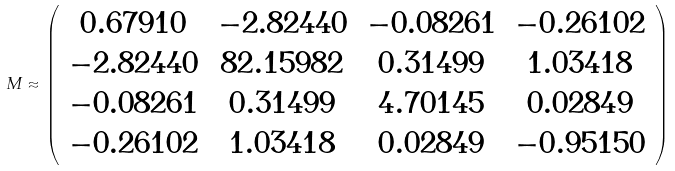<formula> <loc_0><loc_0><loc_500><loc_500>M \approx \left ( \begin{array} { c c c c } 0 . 6 7 9 1 0 & - 2 . 8 2 4 4 0 & - 0 . 0 8 2 6 1 & - 0 . 2 6 1 0 2 \\ - 2 . 8 2 4 4 0 & 8 2 . 1 5 9 8 2 & 0 . 3 1 4 9 9 & 1 . 0 3 4 1 8 \\ - 0 . 0 8 2 6 1 & 0 . 3 1 4 9 9 & 4 . 7 0 1 4 5 & 0 . 0 2 8 4 9 \\ - 0 . 2 6 1 0 2 & 1 . 0 3 4 1 8 & 0 . 0 2 8 4 9 & - 0 . 9 5 1 5 0 \end{array} \right )</formula> 